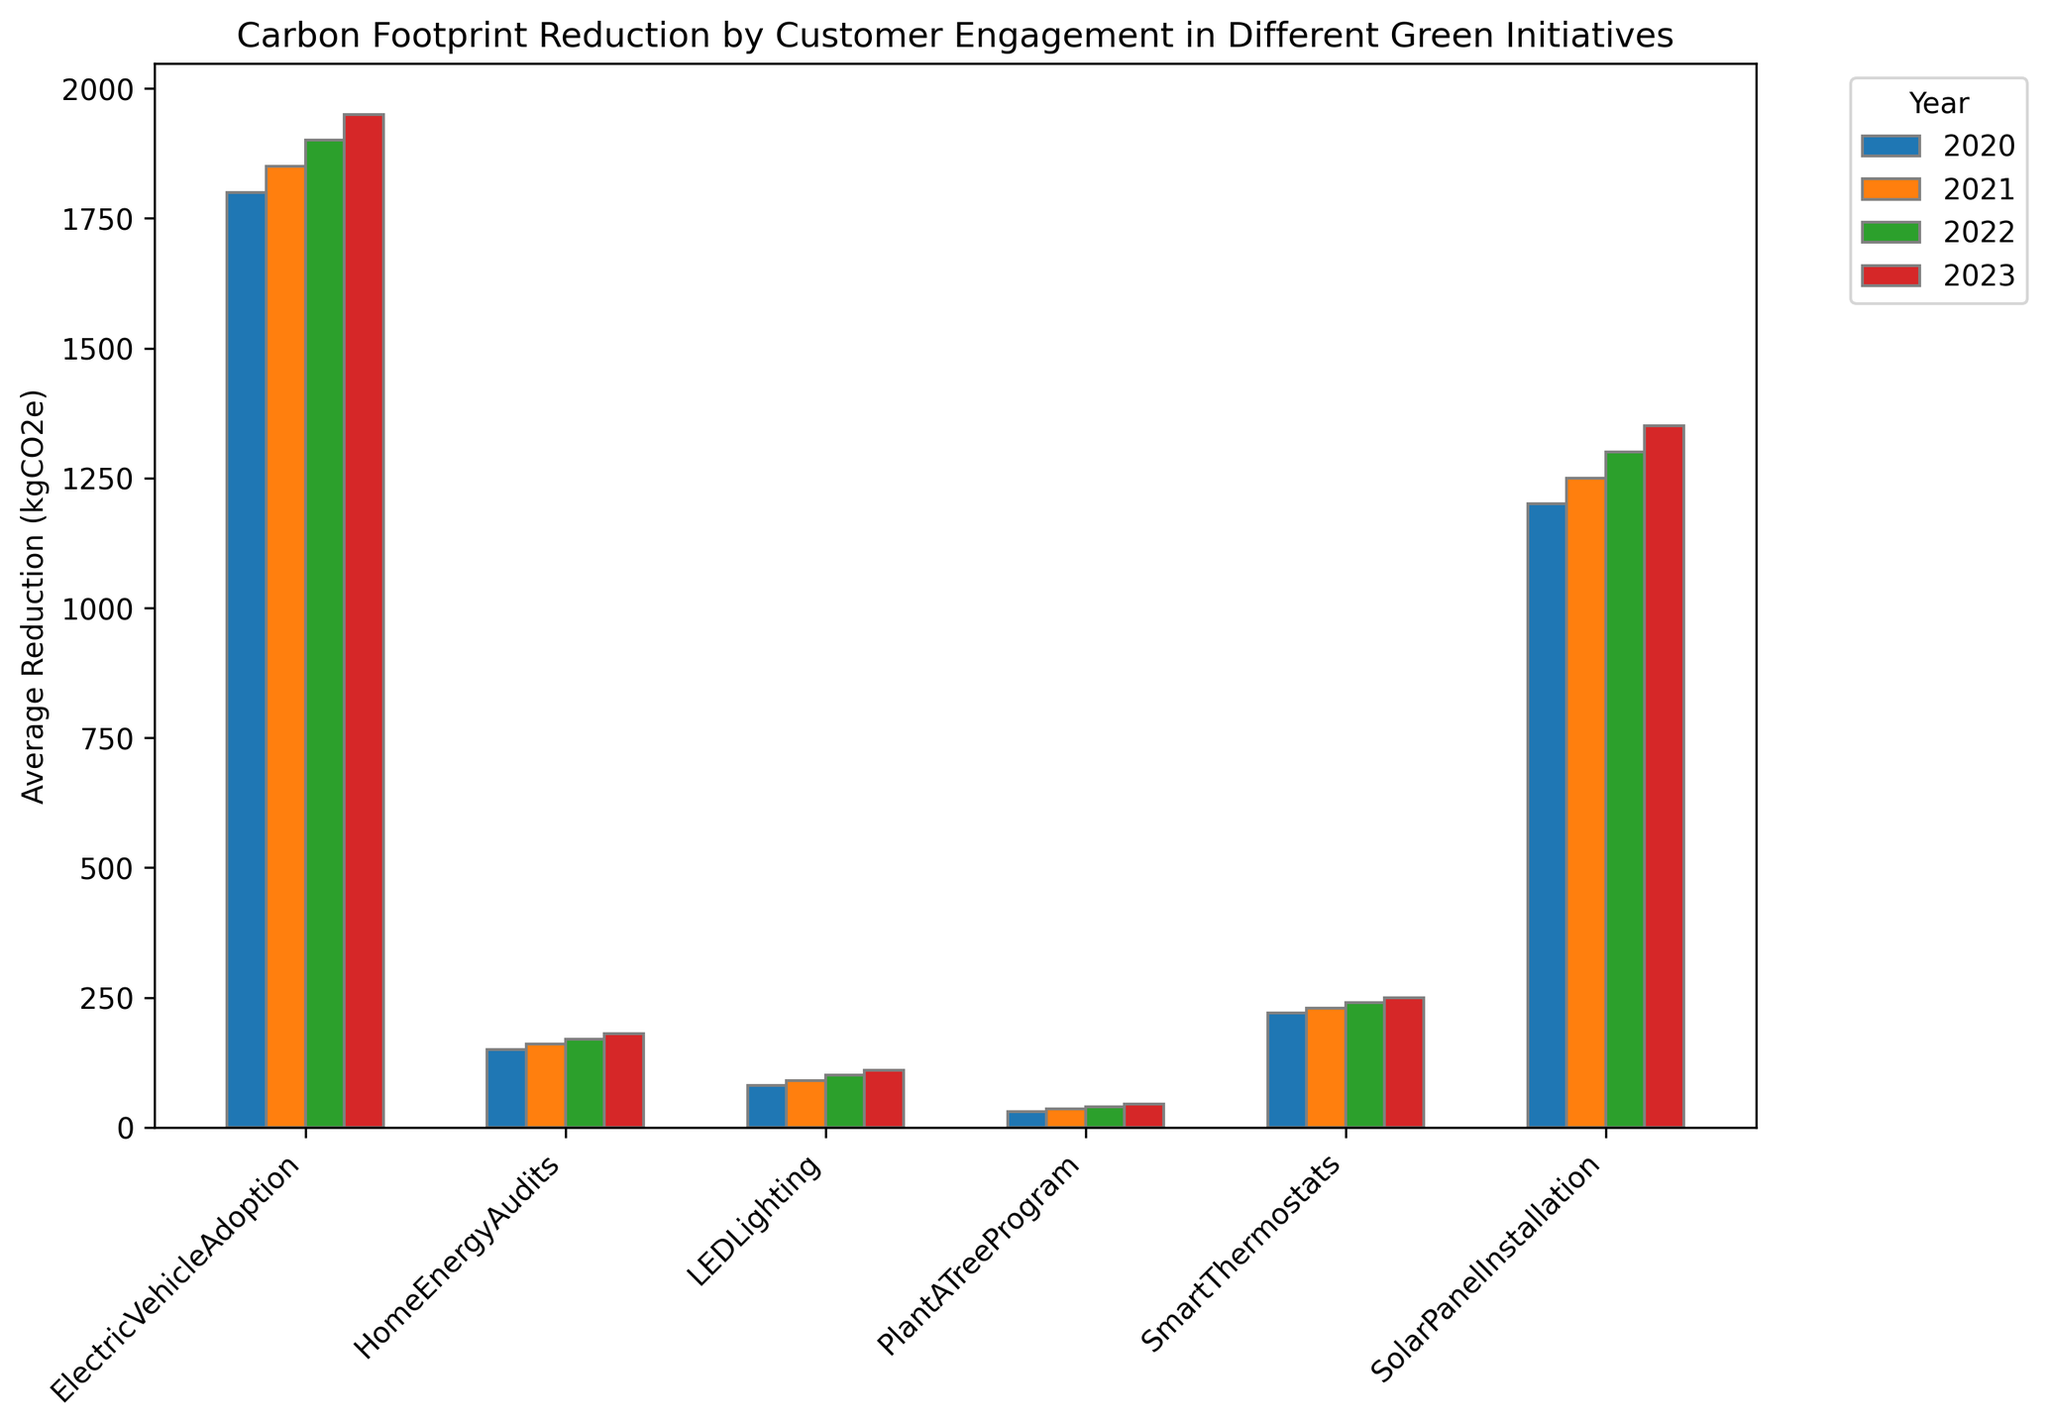What was the average carbon footprint reduction in 2023 for the 'Smart Thermostats' initiative? Look for the 'Smart Thermostats' bar labeled for the year 2023 and read the numerical value from the y-axis.
Answer: 250 kgCO2e Which green initiative had the highest carbon footprint reduction in 2023? Identify the tallest bar for the year 2023 and associate it with its respective initiative label.
Answer: Electric Vehicle Adoption Compare the carbon footprint reduction of 'Solar Panel Installation' in 2020 and 2023; which year had a higher reduction and by how much? Find the heights of the 'Solar Panel Installation' bars for 2020 and 2023, and then subtract the 2020 value from the 2023 value.
Answer: 2023 had a higher reduction by 150 kgCO2e Which green initiative showed a consistent increase in carbon footprint reduction from 2020 to 2023? Examine the trends for each initiative across the years. Identify the initiative whose bars consistently increase in height from 2020 to 2023.
Answer: Home Energy Audits What is the combined average carbon footprint reduction of 'LED Lighting' over all years shown? Sum the average reductions of 'LED Lighting' for all years and then divide by the number of years (4).
Answer: (80 + 90 + 100 + 110) / 4 = 95 kgCO2e What is the total carbon footprint reduction from 'Plant A Tree Program' over the four years? Sum the values for the 'Plant A Tree Program' across all four years.
Answer: 30 + 35 + 40 + 45 = 150 kgCO2e Which initiative had the lowest average carbon footprint reduction across all years? Calculate the average reduction for each initiative over the years and identify the lowest average.
Answer: Plant A Tree Program By how much did the average footprint reduction for the 'Home Energy Audits' initiative increase from 2020 to 2021? Subtract the 2020 value from the 2021 value for 'Home Energy Audits'.
Answer: 160 - 150 = 10 kgCO2e How does the 'Smart Thermostats' reduction in 2021 compare to 'LED Lighting' in 2023? Compare the heights of the 'Smart Thermostats' bar in 2021 and the 'LED Lighting' bar in 2023.
Answer: Smart Thermostats had a higher reduction What's the average carbon footprint reduction for 'Electric Vehicle Adoption' between 2020 and 2023? Sum the values for 'Electric Vehicle Adoption' from 2020 to 2023 and divide by the number of years (4).
Answer: (1800 + 1850 + 1900 + 1950) / 4 = 1875 kgCO2e 